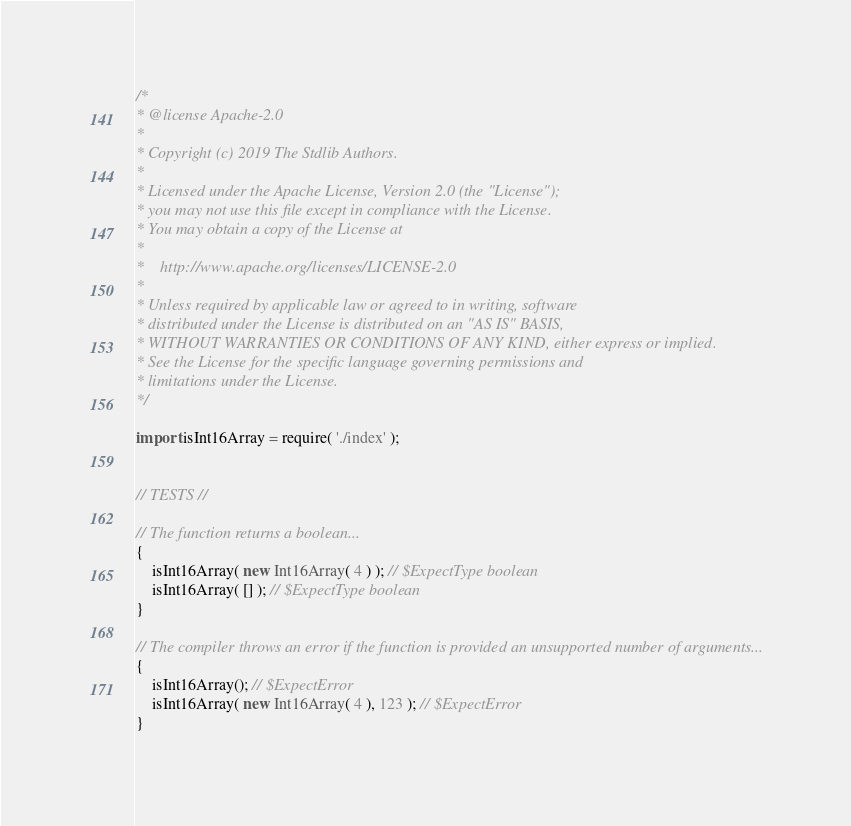<code> <loc_0><loc_0><loc_500><loc_500><_TypeScript_>/*
* @license Apache-2.0
*
* Copyright (c) 2019 The Stdlib Authors.
*
* Licensed under the Apache License, Version 2.0 (the "License");
* you may not use this file except in compliance with the License.
* You may obtain a copy of the License at
*
*    http://www.apache.org/licenses/LICENSE-2.0
*
* Unless required by applicable law or agreed to in writing, software
* distributed under the License is distributed on an "AS IS" BASIS,
* WITHOUT WARRANTIES OR CONDITIONS OF ANY KIND, either express or implied.
* See the License for the specific language governing permissions and
* limitations under the License.
*/

import isInt16Array = require( './index' );


// TESTS //

// The function returns a boolean...
{
	isInt16Array( new Int16Array( 4 ) ); // $ExpectType boolean
	isInt16Array( [] ); // $ExpectType boolean
}

// The compiler throws an error if the function is provided an unsupported number of arguments...
{
	isInt16Array(); // $ExpectError
	isInt16Array( new Int16Array( 4 ), 123 ); // $ExpectError
}
</code> 